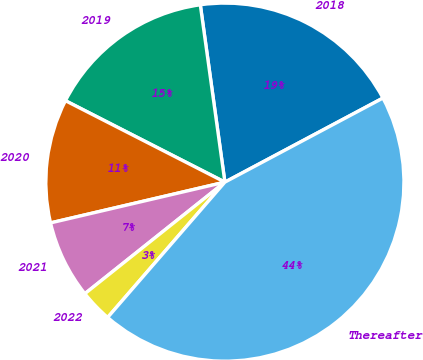<chart> <loc_0><loc_0><loc_500><loc_500><pie_chart><fcel>2018<fcel>2019<fcel>2020<fcel>2021<fcel>2022<fcel>Thereafter<nl><fcel>19.41%<fcel>15.29%<fcel>11.17%<fcel>7.05%<fcel>2.93%<fcel>44.14%<nl></chart> 